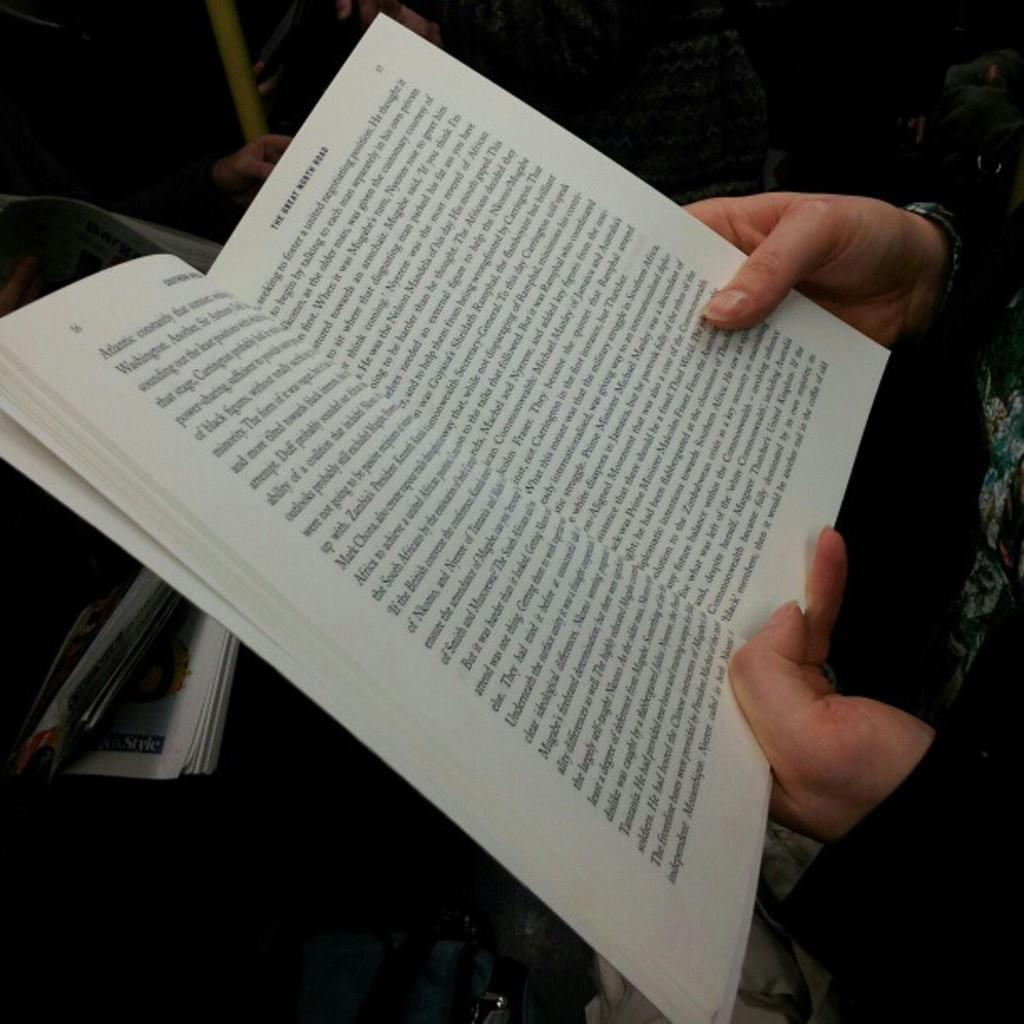What is the main subject of the image? There is a person in the image. What is the person holding in the image? The person is holding a book. Can you describe the contents of the book? There is writing in the book. What type of flight can be seen in the image? There is no flight present in the image; it features a person holding a book with writing. What is the current state of the person in the image? The provided facts do not give any information about the person's current state, only that they are holding a book with writing. 